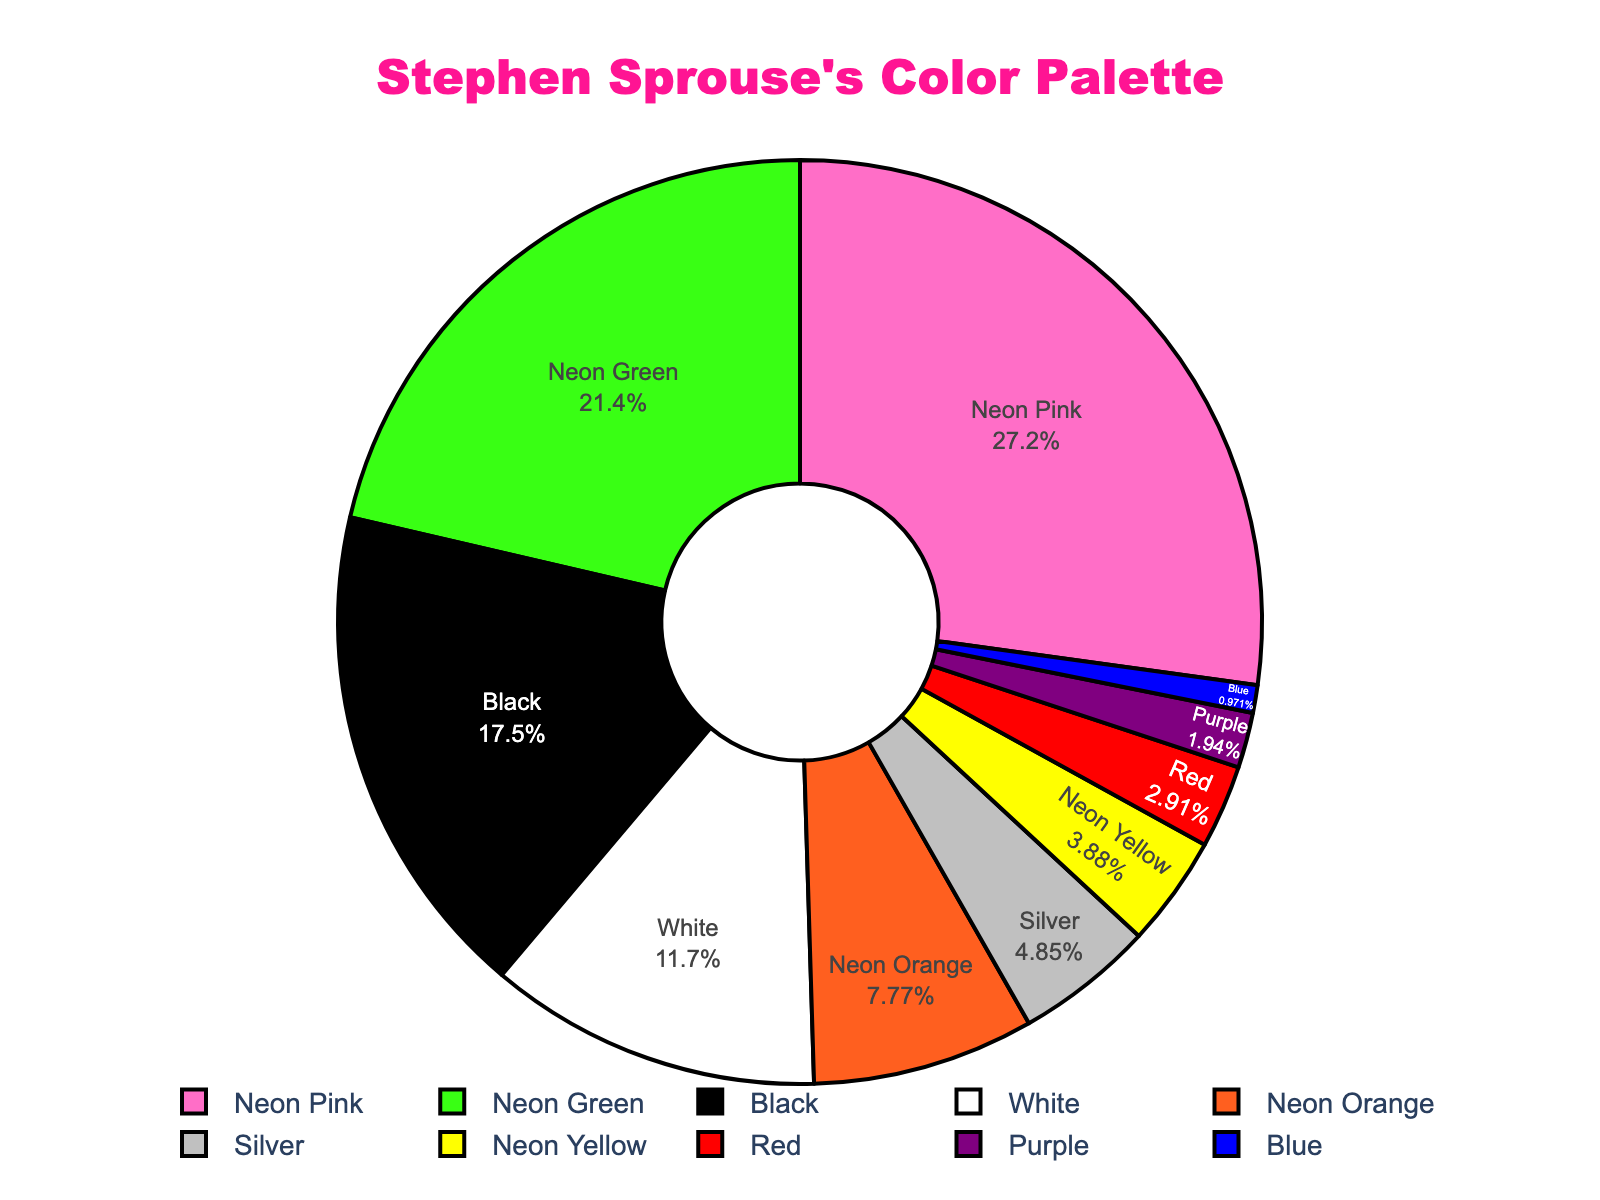What's the most frequently used color in Stephen Sprouse's collections? The pie chart shows the usage percentage of colors. The color with the highest percentage (largest slice) is Neon Pink at 28%.
Answer: Neon Pink Which color has the least representation on the pie chart? Examining the pie chart, the smallest slice with the lowest percentage (1%) belongs to Blue.
Answer: Blue What is the combined percentage of all neon colors in the collections? Add the percentages of Neon Pink (28%), Neon Green (22%), Neon Orange (8%), and Neon Yellow (4%): 28 + 22 + 8 + 4 = 62%.
Answer: 62% How much more frequently is Black used compared to Red? The percentage for Black is 18% and for Red it is 3%. Subtracting these gives 18 - 3 = 15%.
Answer: 15% What is the difference in usage between the most and least used colors? The most used color is Neon Pink at 28% and the least used color is Blue at 1%. Subtracting these gives 28 - 1 = 27%.
Answer: 27% Is there any color used in exactly 5% of the collections? Checking the chart, Silver has a usage percentage of exactly 5%.
Answer: Silver What is the total percentage of usage for Black and White combined? Adding the percentages of Black (18%) and White (12%): 18 + 12 = 30%.
Answer: 30% How does the usage of Silver compare to that of Neon Yellow? Silver is used at 5% and Neon Yellow is used at 4%. Silver has a 1% higher usage than Neon Yellow.
Answer: 1% Which two colors have the closest usage percentages and what is the difference between them? Checking the percentages, Red (3%) and Purple (2%) are the closest. The difference is 3 - 2 = 1%.
Answer: Red and Purple, 1% If you combined the usage of Neon Orange and Purple, how much percentage would that be? Adding the percentages of Neon Orange (8%) and Purple (2%): 8 + 2 = 10%.
Answer: 10% 